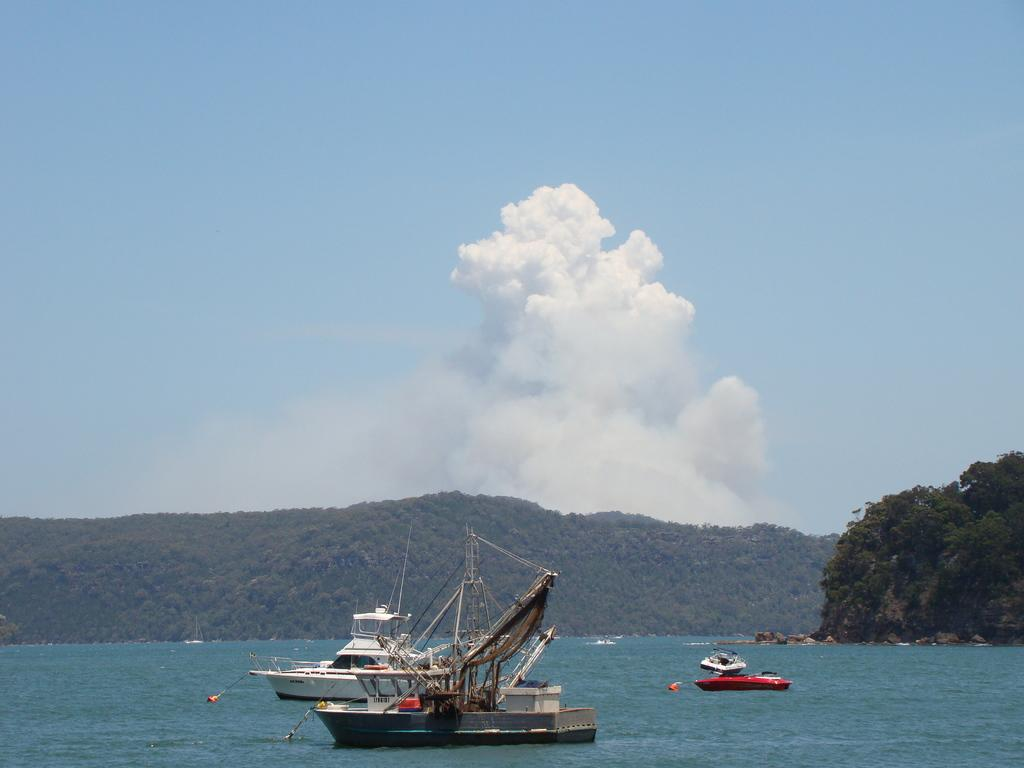What types of watercraft are in the water in the image? There are ships and boats in the water in the image. What can be seen in the background of the image? There is greenery in the background. What is the color of the sky in the image? The sky is blue in color. What is the weather like in the image? The sky is cloudy, suggesting a partly cloudy day. What type of flower is being cared for on the ship in the image? There are no flowers visible in the image, and the ships and boats are not shown to be caring for any flowers. 